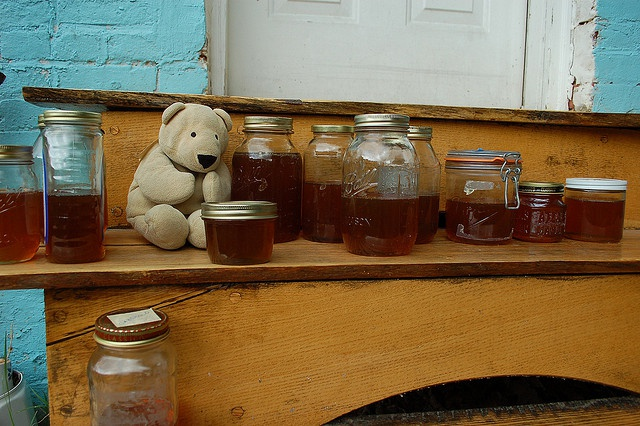Describe the objects in this image and their specific colors. I can see teddy bear in teal, tan, olive, and gray tones, bottle in teal, maroon, gray, and olive tones, bottle in teal, maroon, darkgray, and gray tones, bottle in teal, black, gray, and maroon tones, and bottle in teal, black, olive, and maroon tones in this image. 